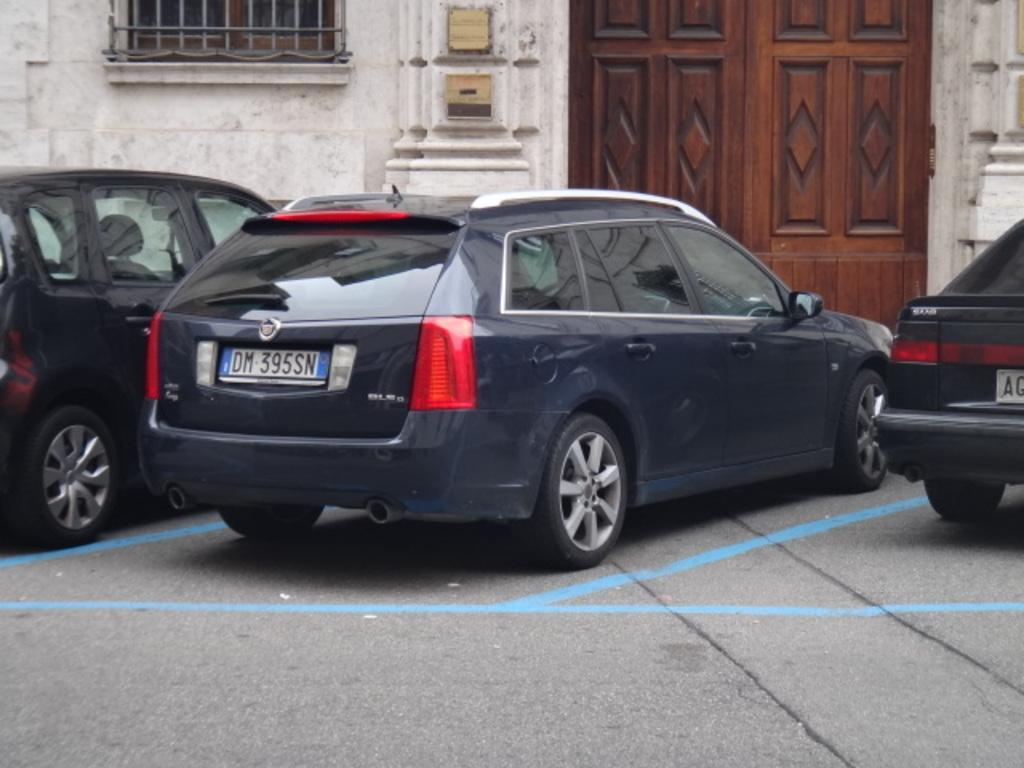What can be seen on the ground in the image? There are vehicles on the ground in the image. What is in front of the vehicles? There is a wall in front of the vehicles. What features does the wall have? The wall has a window, a grille, and a door. What is attached to the wall? There are boxes attached to the wall. Can you hear the horn of the vehicle in the image? There is not present in the image, so it is not possible to hear any sounds. 